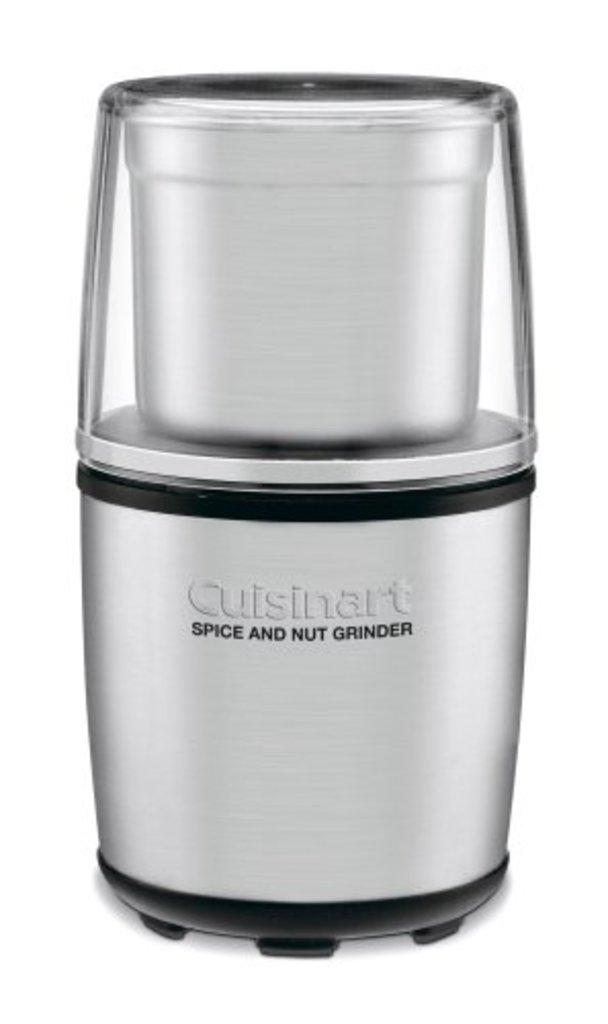<image>
Describe the image concisely. A kitchen appliance with the words Cuisinart spice and nut grinder written on it. 